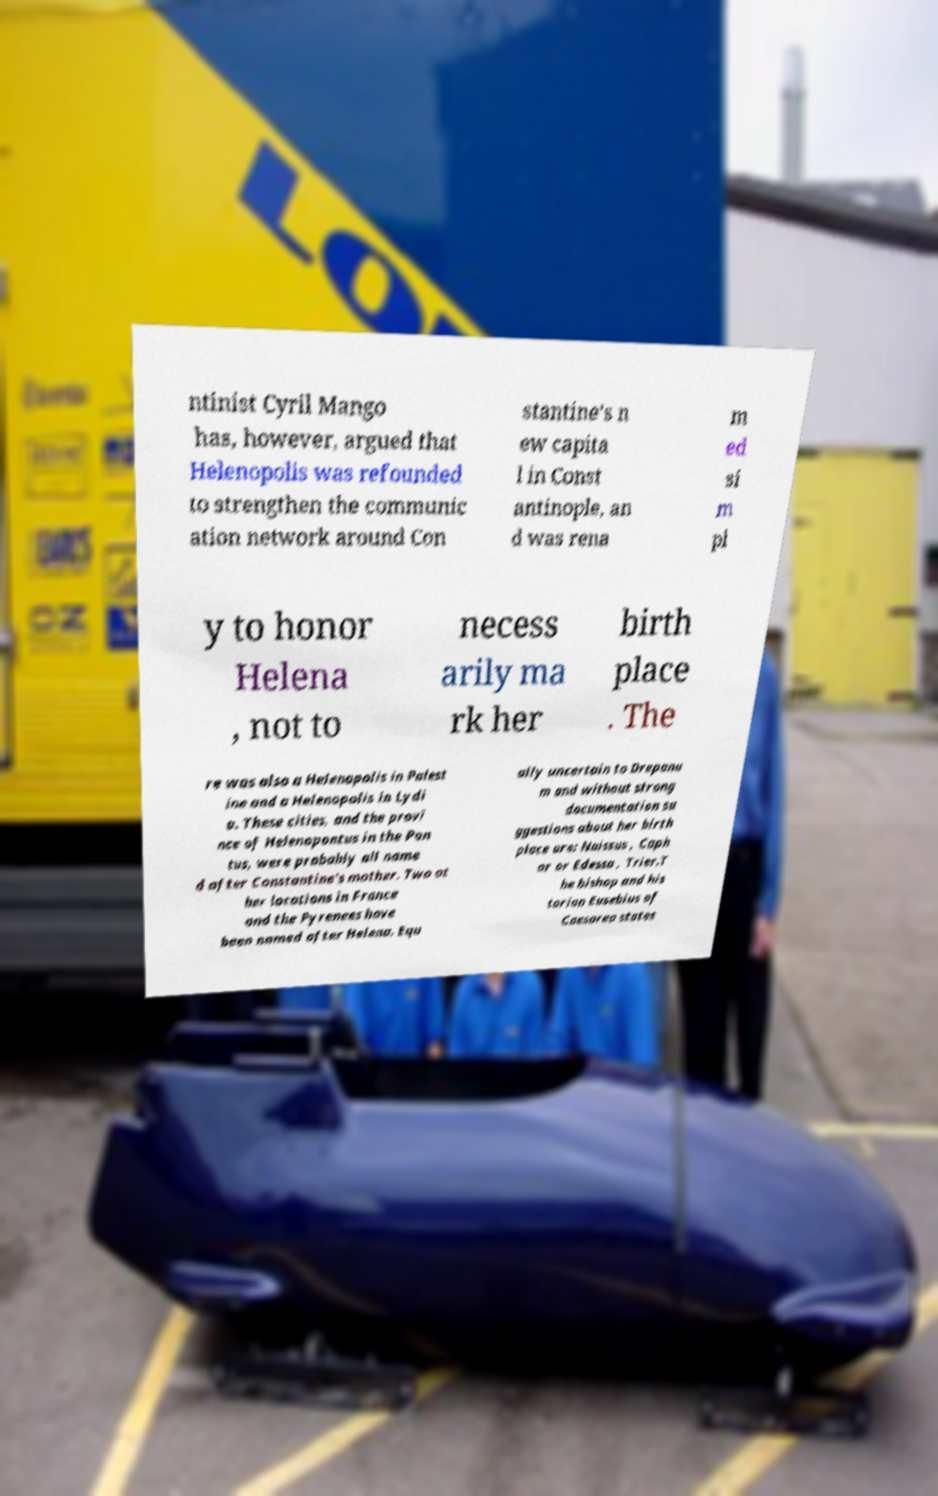Please read and relay the text visible in this image. What does it say? ntinist Cyril Mango has, however, argued that Helenopolis was refounded to strengthen the communic ation network around Con stantine's n ew capita l in Const antinople, an d was rena m ed si m pl y to honor Helena , not to necess arily ma rk her birth place . The re was also a Helenopolis in Palest ine and a Helenopolis in Lydi a. These cities, and the provi nce of Helenopontus in the Pon tus, were probably all name d after Constantine's mother. Two ot her locations in France and the Pyrenees have been named after Helena. Equ ally uncertain to Drepanu m and without strong documentation su ggestions about her birth place are: Naissus , Caph ar or Edessa , Trier.T he bishop and his torian Eusebius of Caesarea states 